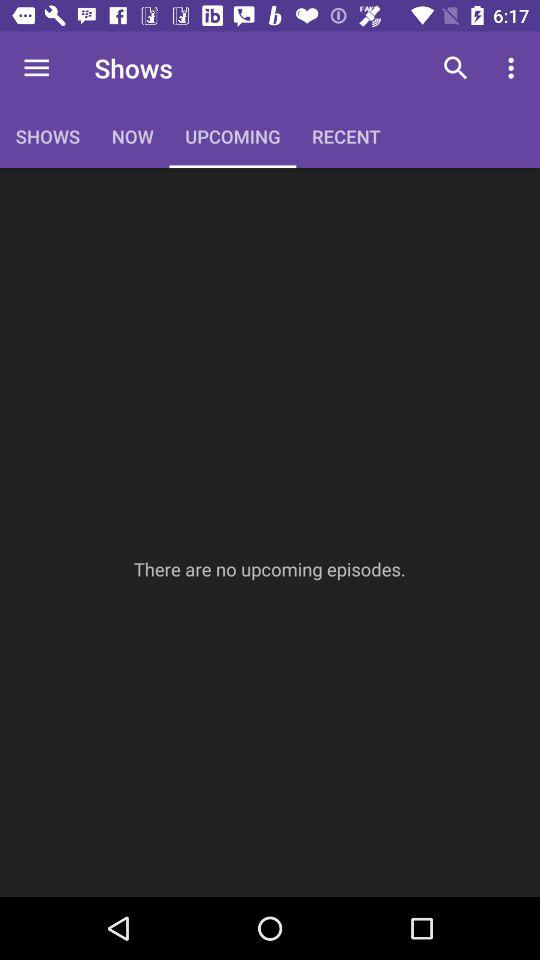Which option is selected in "Shows"? The selected option is "UPCOMING". 